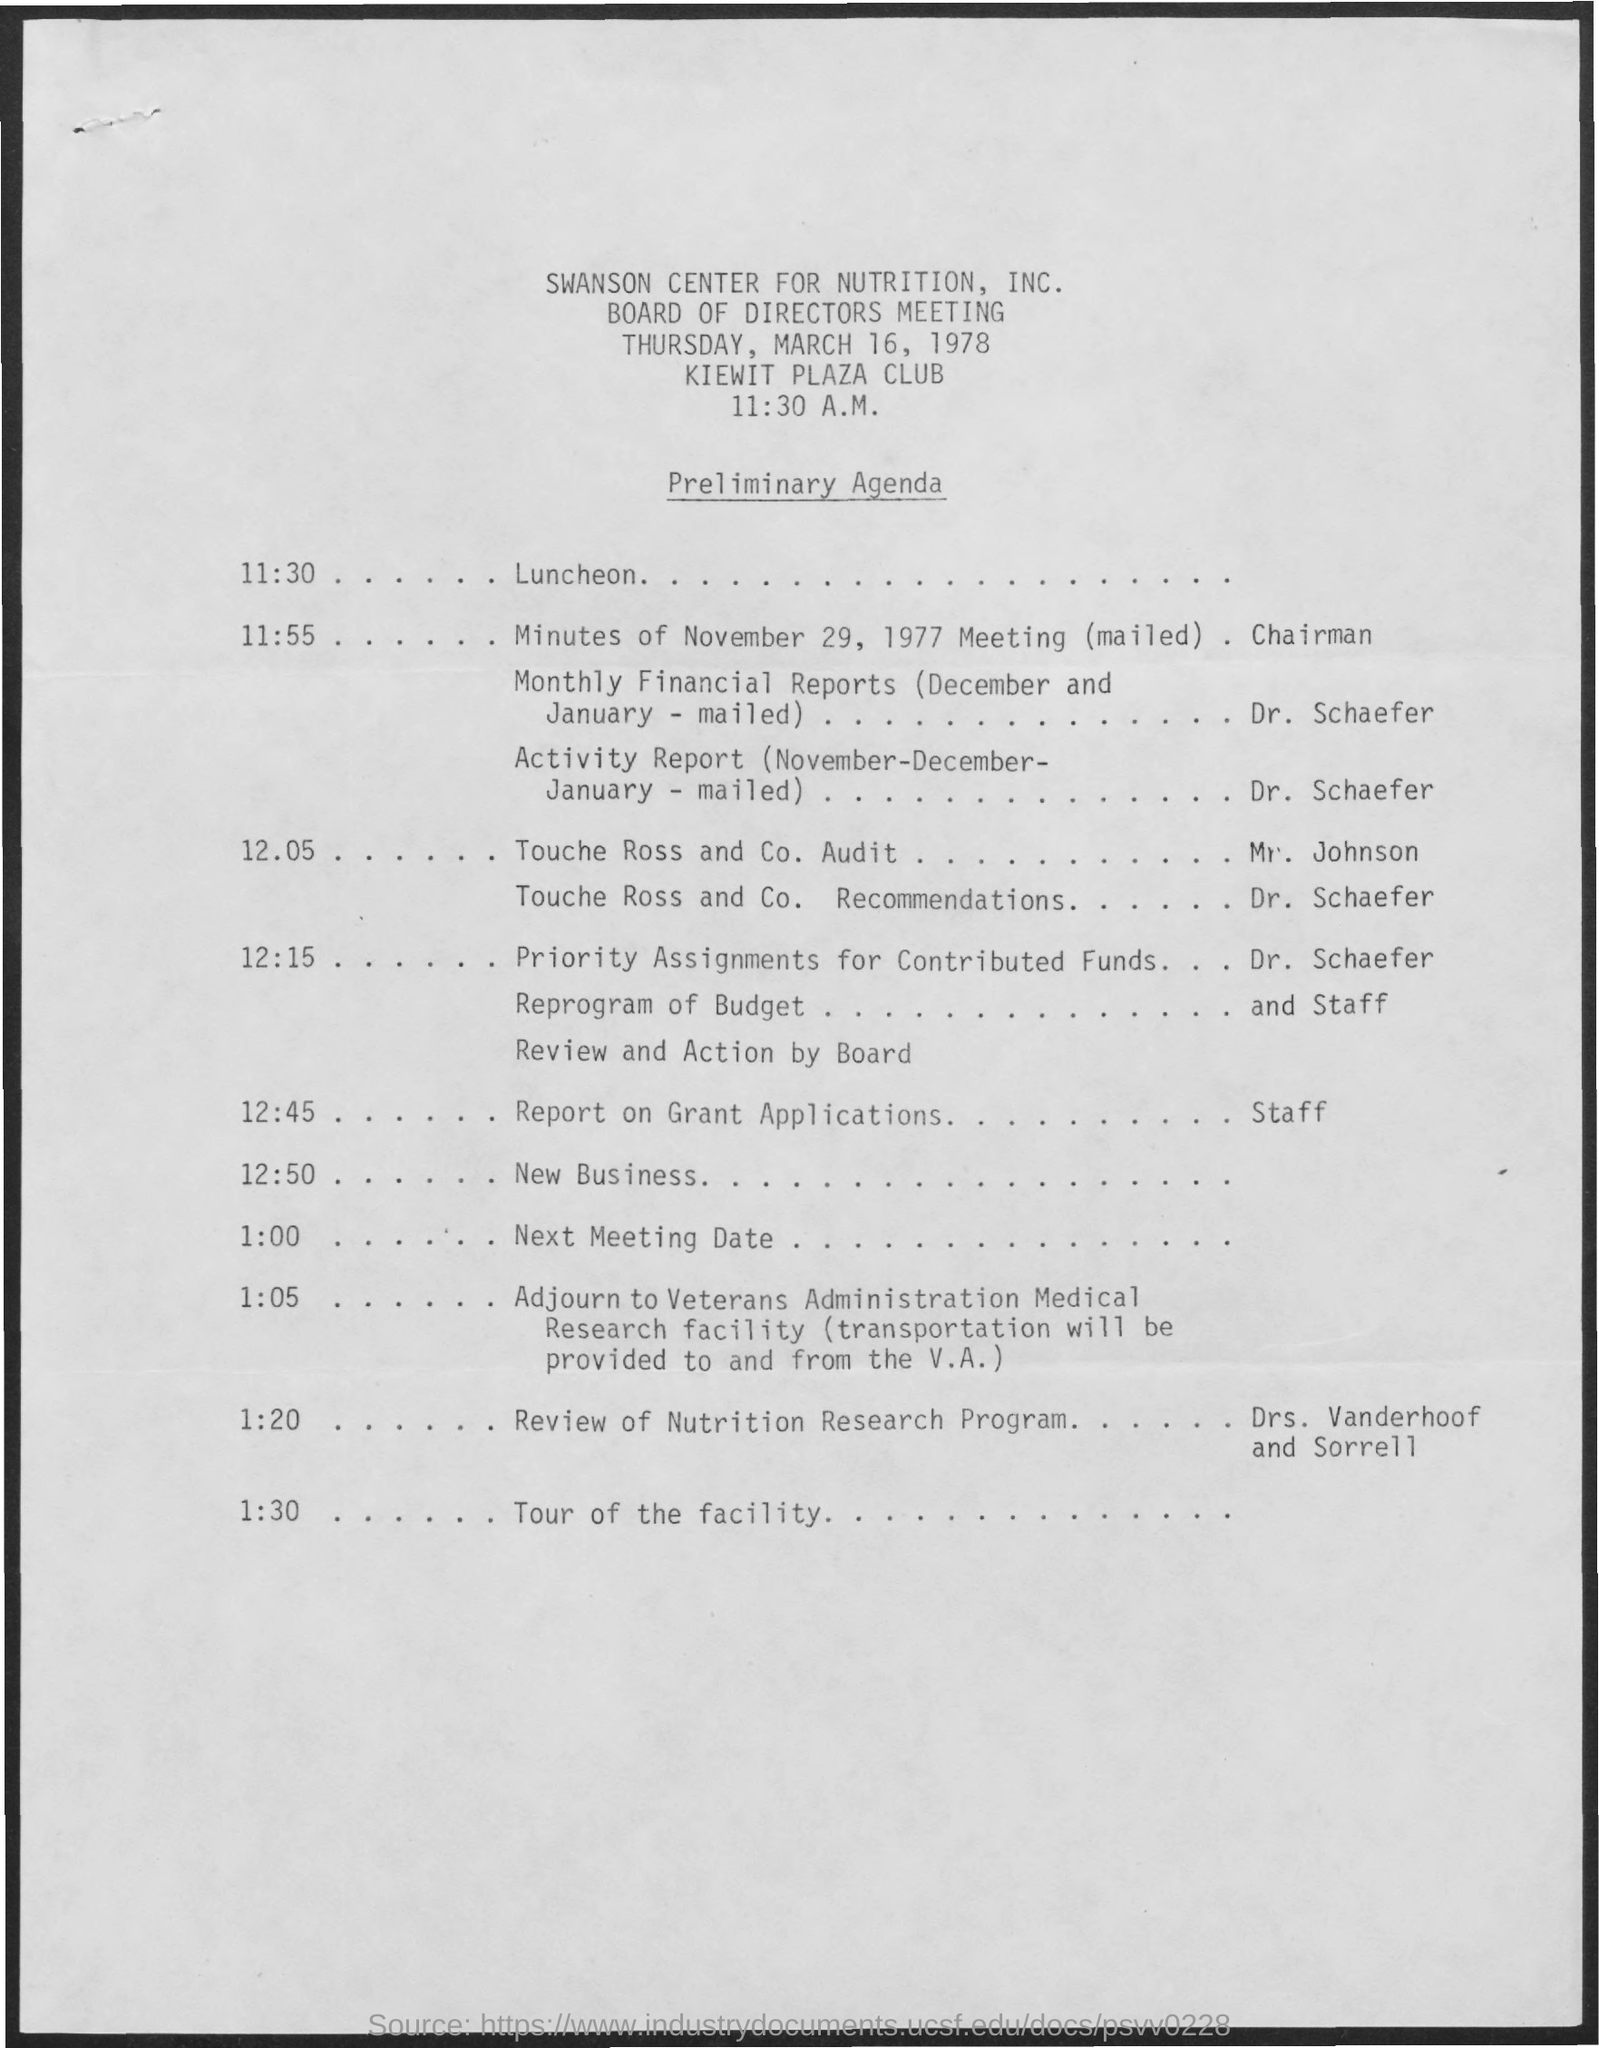Indicate a few pertinent items in this graphic. The name of the meeting is a Board of Directors meeting. At 11:30 a.m., the schedule is as follows: it is luncheon time. The club mentioned is called Kiewit Plaza Club. 